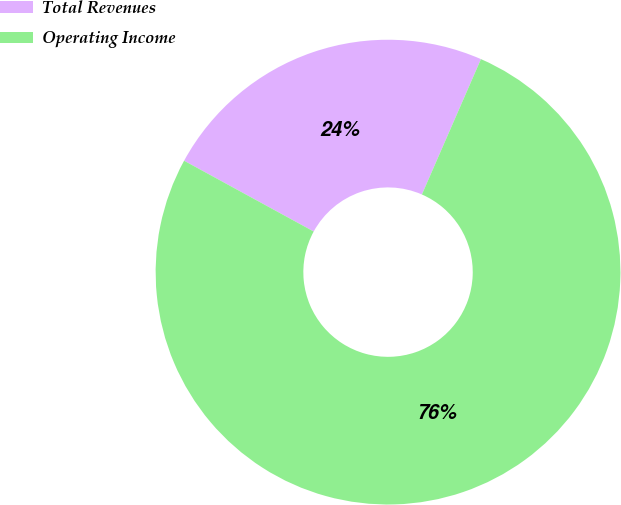<chart> <loc_0><loc_0><loc_500><loc_500><pie_chart><fcel>Total Revenues<fcel>Operating Income<nl><fcel>23.59%<fcel>76.41%<nl></chart> 